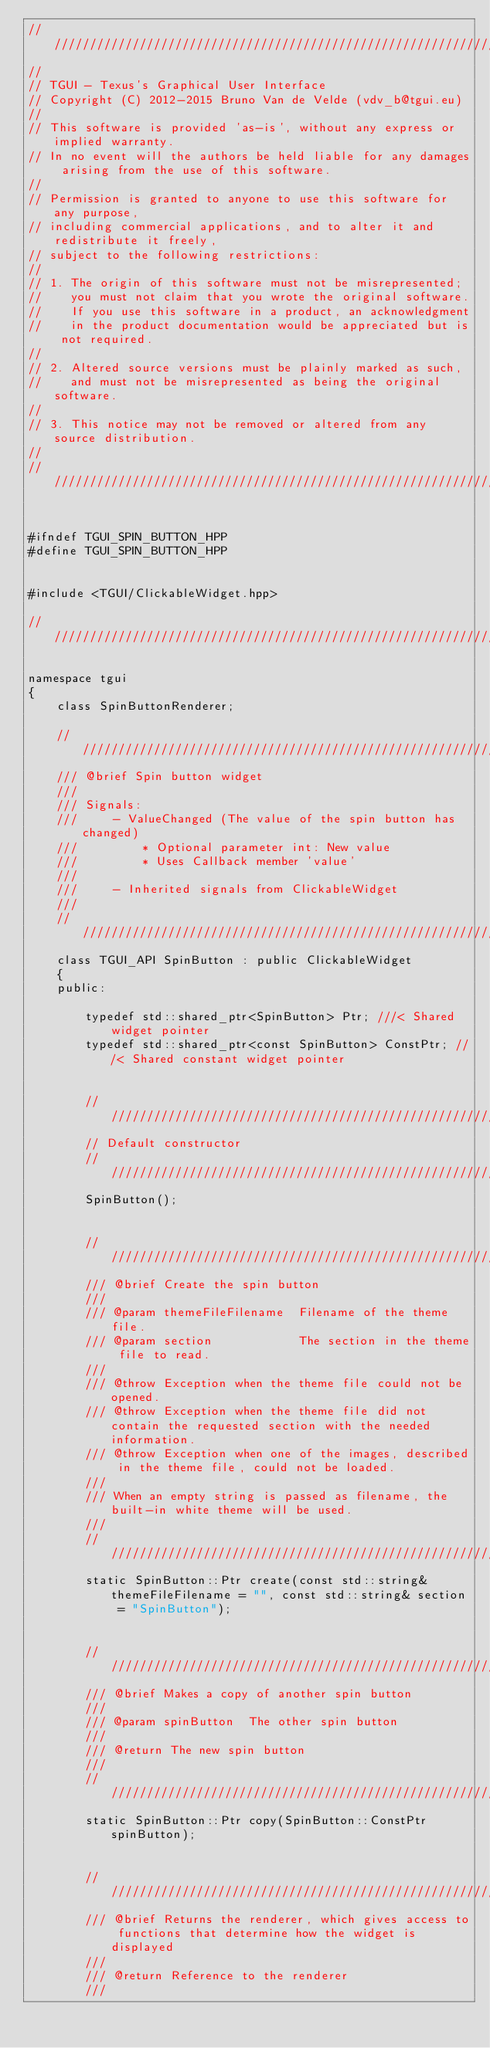Convert code to text. <code><loc_0><loc_0><loc_500><loc_500><_C++_>/////////////////////////////////////////////////////////////////////////////////////////////////////////////////////////////////
//
// TGUI - Texus's Graphical User Interface
// Copyright (C) 2012-2015 Bruno Van de Velde (vdv_b@tgui.eu)
//
// This software is provided 'as-is', without any express or implied warranty.
// In no event will the authors be held liable for any damages arising from the use of this software.
//
// Permission is granted to anyone to use this software for any purpose,
// including commercial applications, and to alter it and redistribute it freely,
// subject to the following restrictions:
//
// 1. The origin of this software must not be misrepresented;
//    you must not claim that you wrote the original software.
//    If you use this software in a product, an acknowledgment
//    in the product documentation would be appreciated but is not required.
//
// 2. Altered source versions must be plainly marked as such,
//    and must not be misrepresented as being the original software.
//
// 3. This notice may not be removed or altered from any source distribution.
//
/////////////////////////////////////////////////////////////////////////////////////////////////////////////////////////////////


#ifndef TGUI_SPIN_BUTTON_HPP
#define TGUI_SPIN_BUTTON_HPP


#include <TGUI/ClickableWidget.hpp>

/////////////////////////////////////////////////////////////////////////////////////////////////////////////////////////////////

namespace tgui
{
    class SpinButtonRenderer;

    /////////////////////////////////////////////////////////////////////////////////////////////////////////////////////////////
    /// @brief Spin button widget
    ///
    /// Signals:
    ///     - ValueChanged (The value of the spin button has changed)
    ///         * Optional parameter int: New value
    ///         * Uses Callback member 'value'
    ///
    ///     - Inherited signals from ClickableWidget
    ///
    /////////////////////////////////////////////////////////////////////////////////////////////////////////////////////////////
    class TGUI_API SpinButton : public ClickableWidget
    {
    public:

        typedef std::shared_ptr<SpinButton> Ptr; ///< Shared widget pointer
        typedef std::shared_ptr<const SpinButton> ConstPtr; ///< Shared constant widget pointer


        /////////////////////////////////////////////////////////////////////////////////////////////////////////////////////////
        // Default constructor
        /////////////////////////////////////////////////////////////////////////////////////////////////////////////////////////
        SpinButton();


        /////////////////////////////////////////////////////////////////////////////////////////////////////////////////////////
        /// @brief Create the spin button
        ///
        /// @param themeFileFilename  Filename of the theme file.
        /// @param section            The section in the theme file to read.
        ///
        /// @throw Exception when the theme file could not be opened.
        /// @throw Exception when the theme file did not contain the requested section with the needed information.
        /// @throw Exception when one of the images, described in the theme file, could not be loaded.
        ///
        /// When an empty string is passed as filename, the built-in white theme will be used.
        ///
        /////////////////////////////////////////////////////////////////////////////////////////////////////////////////////////
        static SpinButton::Ptr create(const std::string& themeFileFilename = "", const std::string& section = "SpinButton");


        /////////////////////////////////////////////////////////////////////////////////////////////////////////////////////////
        /// @brief Makes a copy of another spin button
        ///
        /// @param spinButton  The other spin button
        ///
        /// @return The new spin button
        ///
        /////////////////////////////////////////////////////////////////////////////////////////////////////////////////////////
        static SpinButton::Ptr copy(SpinButton::ConstPtr spinButton);


        /////////////////////////////////////////////////////////////////////////////////////////////////////////////////////////
        /// @brief Returns the renderer, which gives access to functions that determine how the widget is displayed
        ///
        /// @return Reference to the renderer
        ///</code> 